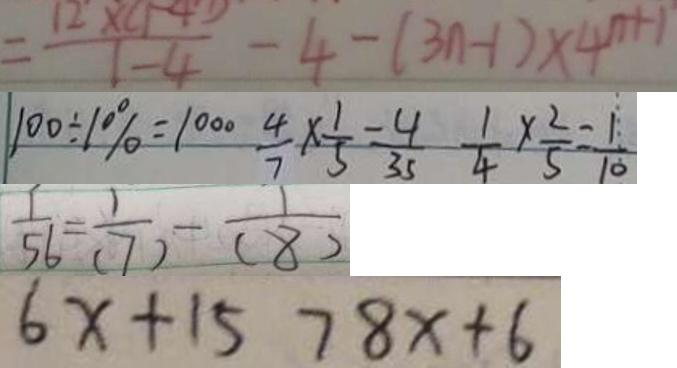<formula> <loc_0><loc_0><loc_500><loc_500>= \frac { 1 2 \times ( 1 - 4 ) } { 1 - 4 } - 4 - ( 3 n - 1 ) \times 4 ^ { n + 1 } 
 1 0 0 \div 1 0 \% = 1 0 0 \frac { 4 } { 7 } \times \frac { 1 } { 5 } = \frac { 4 } { 3 5 } \frac { 1 } { 4 } \times \frac { 2 } { 5 } = \frac { 1 } { 1 0 } 
 \frac { 1 } { 5 6 } = \frac { 1 } { ( 7 ) } - \frac { 1 } { ( 8 ) } 
 6 x + 1 5 7 8 x + 6</formula> 